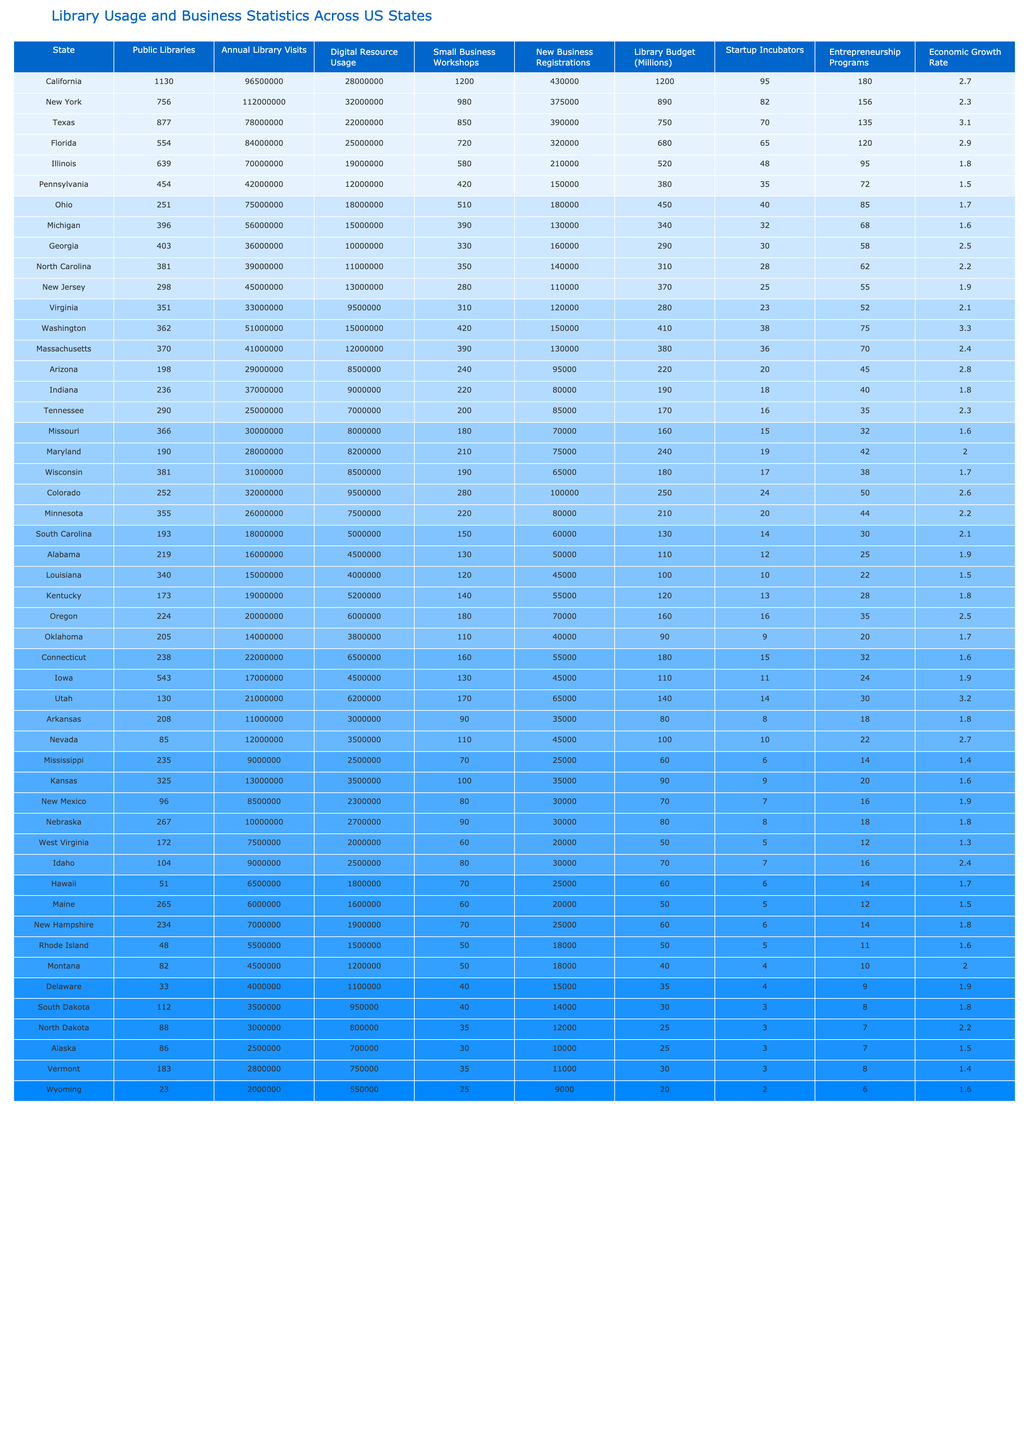What state has the highest number of public libraries? By looking at the "Public Libraries" column, we can see that California has the highest number of public libraries with a total of 1130.
Answer: California Which state had the lowest library budget? The "Library Budget (Millions)" column indicates that Wyoming has the lowest library budget at 20 million.
Answer: Wyoming What is the average number of new business registrations across the states? To find the average, we sum the "New Business Registrations" for all states and divide by the number of states (50). The sum is 4008000, so the average is 4008000/50 = 801600.
Answer: 801600 Which state has the highest economic growth rate? The "Economic Growth Rate" column shows that Texas has the highest economic growth rate at 3.1 percent.
Answer: Texas Is there a correlation between annual library visits and new business registrations? To determine this, we can observe that California has the highest annual visits (96500000) and new business registrations (430000), whereas Mississippi has the lowest visits (9000000) and registrations (25000), suggesting that a trend or correlation might exist. However, a definitive correlation requires statistical analysis.
Answer: No definitive answer without analysis Which state has more small business workshops, Florida or New York? By comparing the "Small Business Workshops" for both states, Florida has 720 workshops while New York has 980 workshops, meaning New York has more.
Answer: New York What percentage of public libraries in the United States are located in California? First, we note California has 1130 libraries, and if we assume the total across all states is 1130 + (sum of all others). The total libraries is 1130 + 3782 = 4912. Therefore, the percentage would be (1130/4912) * 100, which equals approximately 23%.
Answer: 23% Which two states have the same number of small business workshops, and what is that number? On reviewing the "Small Business Workshops" column, Arizona and Indiana both have 220 workshops, making them the two states with the same count.
Answer: 220 How many states have more than 500 small business workshops? Looking at the "Small Business Workshops" column, we can tally the states with workshops exceeding 500, which are California (1200), New York (980), and Texas (850). Thus, there are 3 such states.
Answer: 3 Does New Jersey have more digital resource usage than North Carolina? By comparing the "Digital Resource Usage," New Jersey has 13000000 while North Carolina has 11000000, indicating that New Jersey has higher usage.
Answer: Yes What is the sum of the library budgets for states with an economic growth rate of 2.8 or higher? We identify the relevant states: Texas (750M), Florida (680M), Washington (410M), Arizona (220M), and California (1200M). Their total library budgets equal 750 + 680 + 410 + 220 + 1200 = 3260 million.
Answer: 3260 million Which state has the lowest number of startup incubators? By inspecting the "Startup Incubators" column, we find that Wyoming has the lowest at 20 incubators.
Answer: Wyoming 